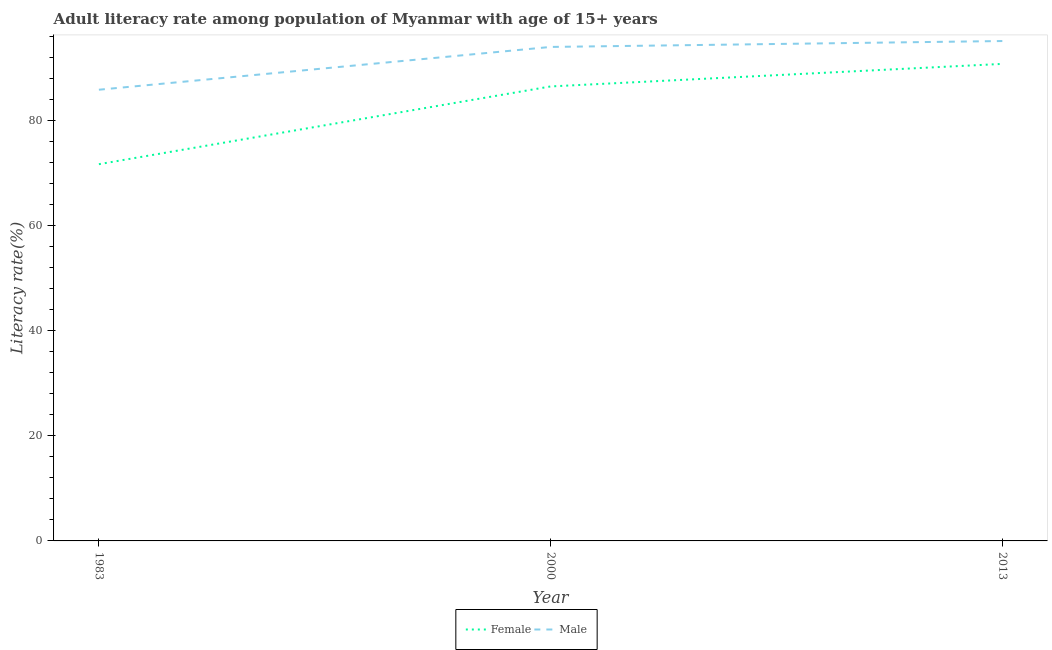Is the number of lines equal to the number of legend labels?
Ensure brevity in your answer.  Yes. What is the female adult literacy rate in 2013?
Ensure brevity in your answer.  90.7. Across all years, what is the maximum female adult literacy rate?
Give a very brief answer. 90.7. Across all years, what is the minimum female adult literacy rate?
Keep it short and to the point. 71.63. In which year was the male adult literacy rate maximum?
Your answer should be compact. 2013. What is the total female adult literacy rate in the graph?
Your answer should be compact. 248.75. What is the difference between the female adult literacy rate in 2000 and that in 2013?
Your answer should be compact. -4.29. What is the difference between the female adult literacy rate in 2013 and the male adult literacy rate in 1983?
Your answer should be compact. 4.91. What is the average male adult literacy rate per year?
Your response must be concise. 91.59. In the year 1983, what is the difference between the male adult literacy rate and female adult literacy rate?
Give a very brief answer. 14.16. In how many years, is the male adult literacy rate greater than 20 %?
Ensure brevity in your answer.  3. What is the ratio of the male adult literacy rate in 2000 to that in 2013?
Your response must be concise. 0.99. What is the difference between the highest and the second highest male adult literacy rate?
Ensure brevity in your answer.  1.12. What is the difference between the highest and the lowest male adult literacy rate?
Give a very brief answer. 9.26. Is the sum of the female adult literacy rate in 1983 and 2000 greater than the maximum male adult literacy rate across all years?
Your answer should be very brief. Yes. Does the male adult literacy rate monotonically increase over the years?
Offer a terse response. Yes. Is the male adult literacy rate strictly greater than the female adult literacy rate over the years?
Make the answer very short. Yes. Is the female adult literacy rate strictly less than the male adult literacy rate over the years?
Keep it short and to the point. Yes. How many lines are there?
Offer a terse response. 2. What is the difference between two consecutive major ticks on the Y-axis?
Provide a short and direct response. 20. Are the values on the major ticks of Y-axis written in scientific E-notation?
Your response must be concise. No. Does the graph contain grids?
Offer a very short reply. No. How many legend labels are there?
Your answer should be very brief. 2. How are the legend labels stacked?
Your answer should be very brief. Horizontal. What is the title of the graph?
Your answer should be compact. Adult literacy rate among population of Myanmar with age of 15+ years. Does "Export" appear as one of the legend labels in the graph?
Ensure brevity in your answer.  No. What is the label or title of the X-axis?
Your answer should be very brief. Year. What is the label or title of the Y-axis?
Your response must be concise. Literacy rate(%). What is the Literacy rate(%) of Female in 1983?
Keep it short and to the point. 71.63. What is the Literacy rate(%) in Male in 1983?
Keep it short and to the point. 85.79. What is the Literacy rate(%) in Female in 2000?
Offer a very short reply. 86.42. What is the Literacy rate(%) of Male in 2000?
Your response must be concise. 93.92. What is the Literacy rate(%) in Female in 2013?
Provide a short and direct response. 90.7. What is the Literacy rate(%) in Male in 2013?
Provide a short and direct response. 95.05. Across all years, what is the maximum Literacy rate(%) in Female?
Your response must be concise. 90.7. Across all years, what is the maximum Literacy rate(%) in Male?
Offer a terse response. 95.05. Across all years, what is the minimum Literacy rate(%) of Female?
Keep it short and to the point. 71.63. Across all years, what is the minimum Literacy rate(%) of Male?
Ensure brevity in your answer.  85.79. What is the total Literacy rate(%) of Female in the graph?
Provide a short and direct response. 248.75. What is the total Literacy rate(%) of Male in the graph?
Provide a succinct answer. 274.76. What is the difference between the Literacy rate(%) in Female in 1983 and that in 2000?
Offer a very short reply. -14.78. What is the difference between the Literacy rate(%) of Male in 1983 and that in 2000?
Provide a short and direct response. -8.14. What is the difference between the Literacy rate(%) in Female in 1983 and that in 2013?
Give a very brief answer. -19.07. What is the difference between the Literacy rate(%) in Male in 1983 and that in 2013?
Ensure brevity in your answer.  -9.26. What is the difference between the Literacy rate(%) in Female in 2000 and that in 2013?
Give a very brief answer. -4.29. What is the difference between the Literacy rate(%) of Male in 2000 and that in 2013?
Provide a short and direct response. -1.12. What is the difference between the Literacy rate(%) in Female in 1983 and the Literacy rate(%) in Male in 2000?
Ensure brevity in your answer.  -22.29. What is the difference between the Literacy rate(%) of Female in 1983 and the Literacy rate(%) of Male in 2013?
Provide a short and direct response. -23.42. What is the difference between the Literacy rate(%) in Female in 2000 and the Literacy rate(%) in Male in 2013?
Make the answer very short. -8.63. What is the average Literacy rate(%) of Female per year?
Offer a terse response. 82.92. What is the average Literacy rate(%) in Male per year?
Keep it short and to the point. 91.59. In the year 1983, what is the difference between the Literacy rate(%) in Female and Literacy rate(%) in Male?
Keep it short and to the point. -14.16. In the year 2000, what is the difference between the Literacy rate(%) in Female and Literacy rate(%) in Male?
Your response must be concise. -7.51. In the year 2013, what is the difference between the Literacy rate(%) of Female and Literacy rate(%) of Male?
Ensure brevity in your answer.  -4.35. What is the ratio of the Literacy rate(%) in Female in 1983 to that in 2000?
Keep it short and to the point. 0.83. What is the ratio of the Literacy rate(%) of Male in 1983 to that in 2000?
Ensure brevity in your answer.  0.91. What is the ratio of the Literacy rate(%) in Female in 1983 to that in 2013?
Offer a very short reply. 0.79. What is the ratio of the Literacy rate(%) of Male in 1983 to that in 2013?
Provide a succinct answer. 0.9. What is the ratio of the Literacy rate(%) of Female in 2000 to that in 2013?
Offer a very short reply. 0.95. What is the ratio of the Literacy rate(%) of Male in 2000 to that in 2013?
Provide a short and direct response. 0.99. What is the difference between the highest and the second highest Literacy rate(%) of Female?
Keep it short and to the point. 4.29. What is the difference between the highest and the second highest Literacy rate(%) in Male?
Ensure brevity in your answer.  1.12. What is the difference between the highest and the lowest Literacy rate(%) of Female?
Offer a terse response. 19.07. What is the difference between the highest and the lowest Literacy rate(%) of Male?
Your answer should be very brief. 9.26. 